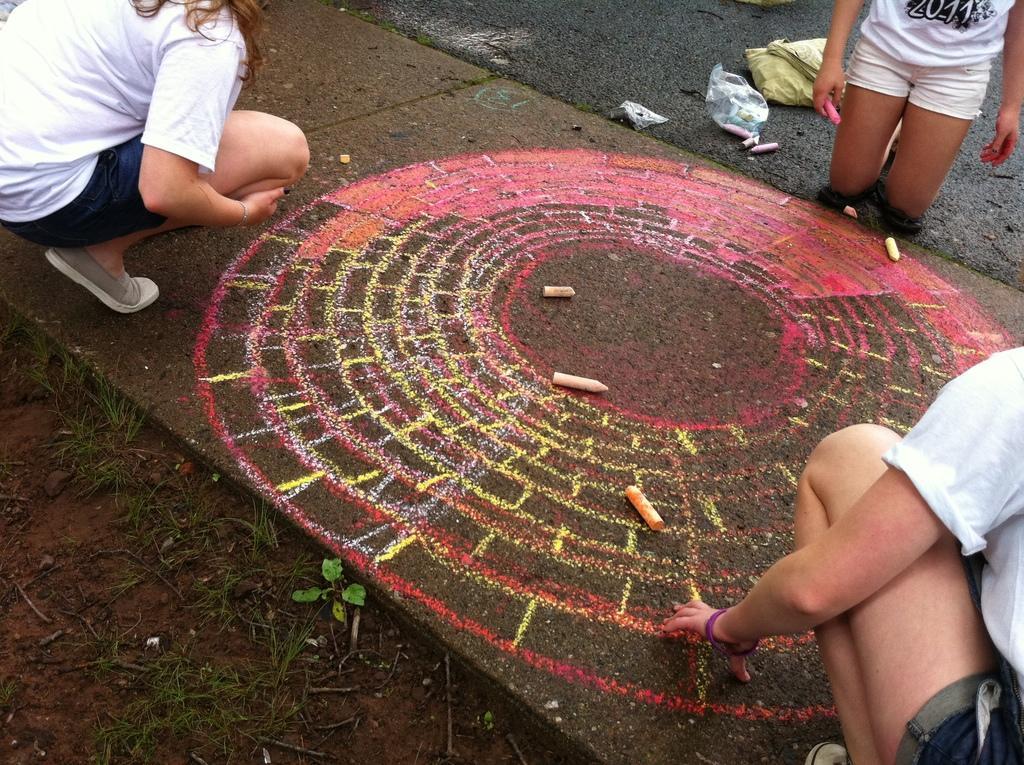How would you summarize this image in a sentence or two? In this image we can see the sidewalk with chalk art and there are some colorful chalks and we can see three persons and one among them holding a chalk. We can see the grass and a small plant on the ground and we can see some other objects. 